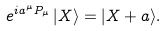Convert formula to latex. <formula><loc_0><loc_0><loc_500><loc_500>e ^ { i a ^ { \mu } P _ { \mu } } \, | X \rangle = | X + a \rangle .</formula> 